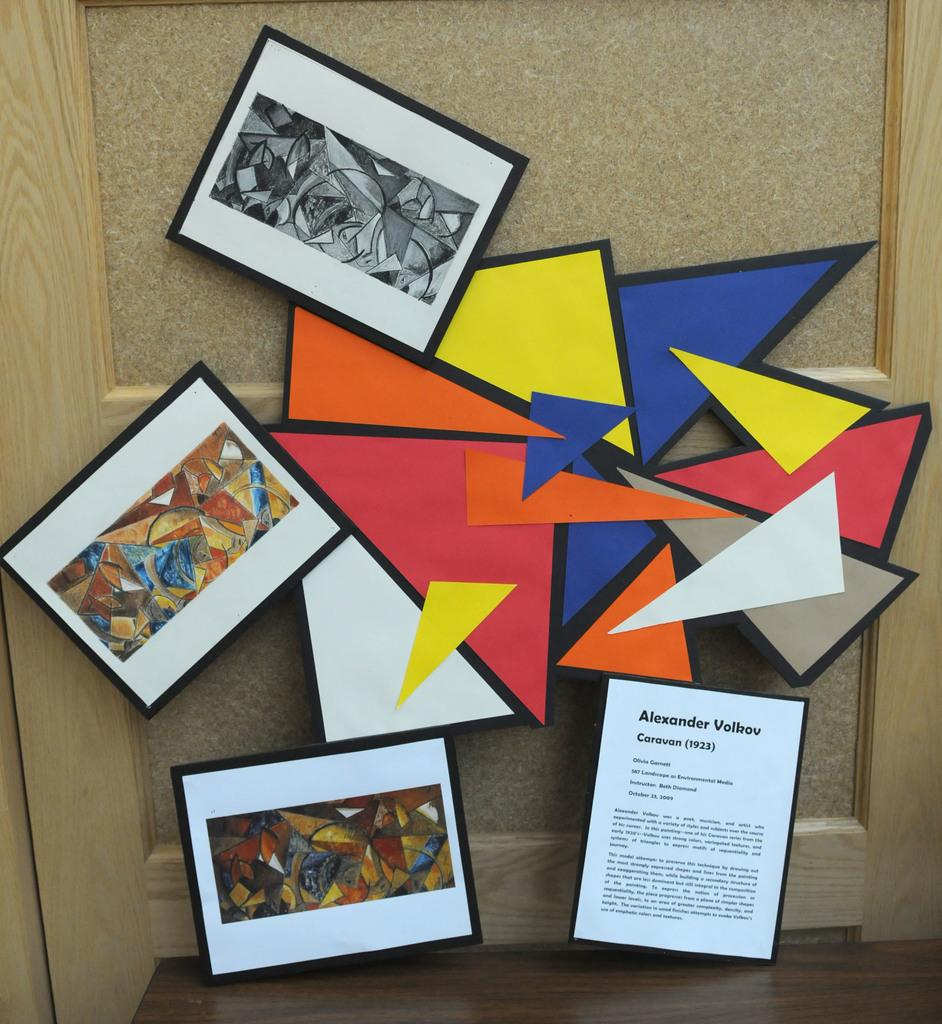<image>
Describe the image concisely. Caravan, the work of an artist named Alexander Volkov, is displayed in a bold, graphic exhibit. 